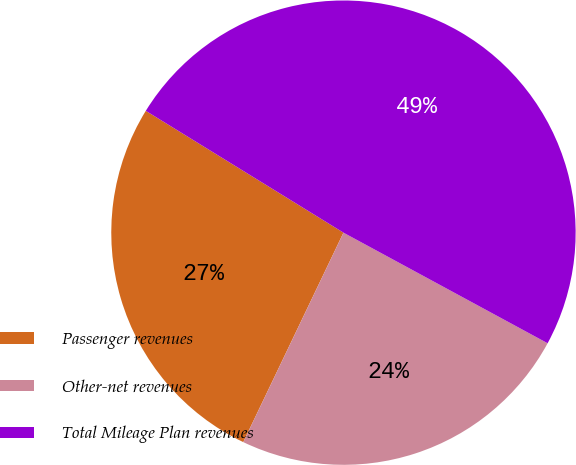Convert chart. <chart><loc_0><loc_0><loc_500><loc_500><pie_chart><fcel>Passenger revenues<fcel>Other-net revenues<fcel>Total Mileage Plan revenues<nl><fcel>26.69%<fcel>24.2%<fcel>49.11%<nl></chart> 